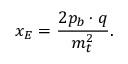Convert formula to latex. <formula><loc_0><loc_0><loc_500><loc_500>x _ { E } = { \frac { 2 p _ { b } \cdot q } { m _ { t } ^ { 2 } } } .</formula> 